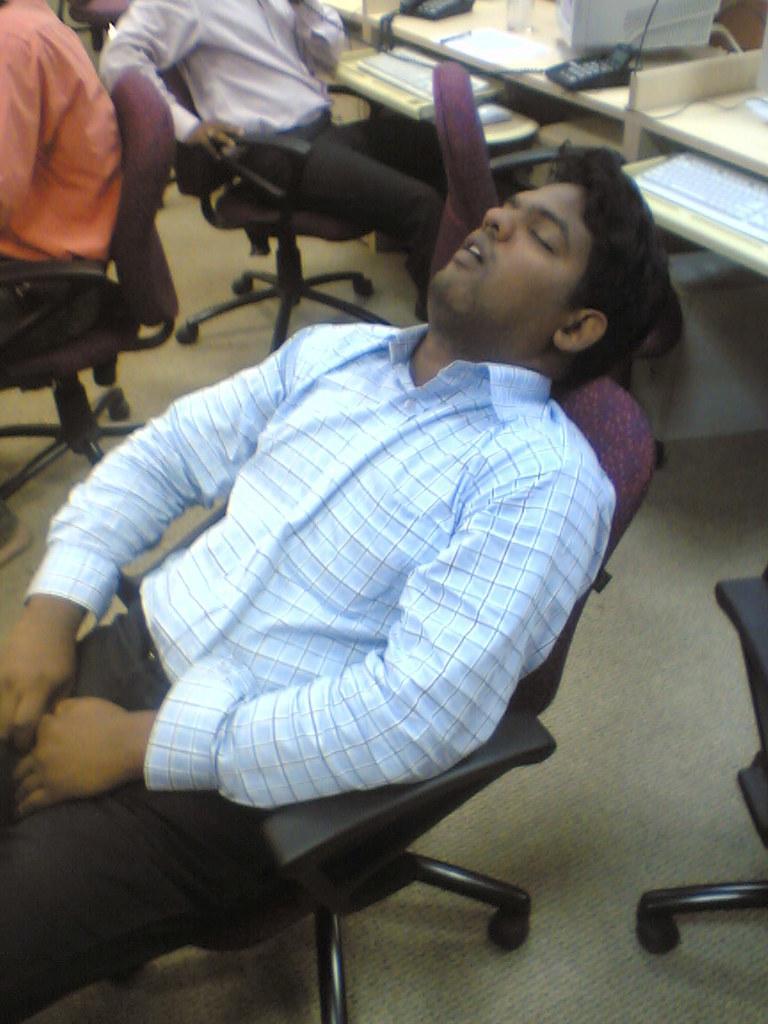Please provide a concise description of this image. In this image I can see a three person sitting on the chair. The man is sleeping. At the back side there is a system,keyboard on the table. 